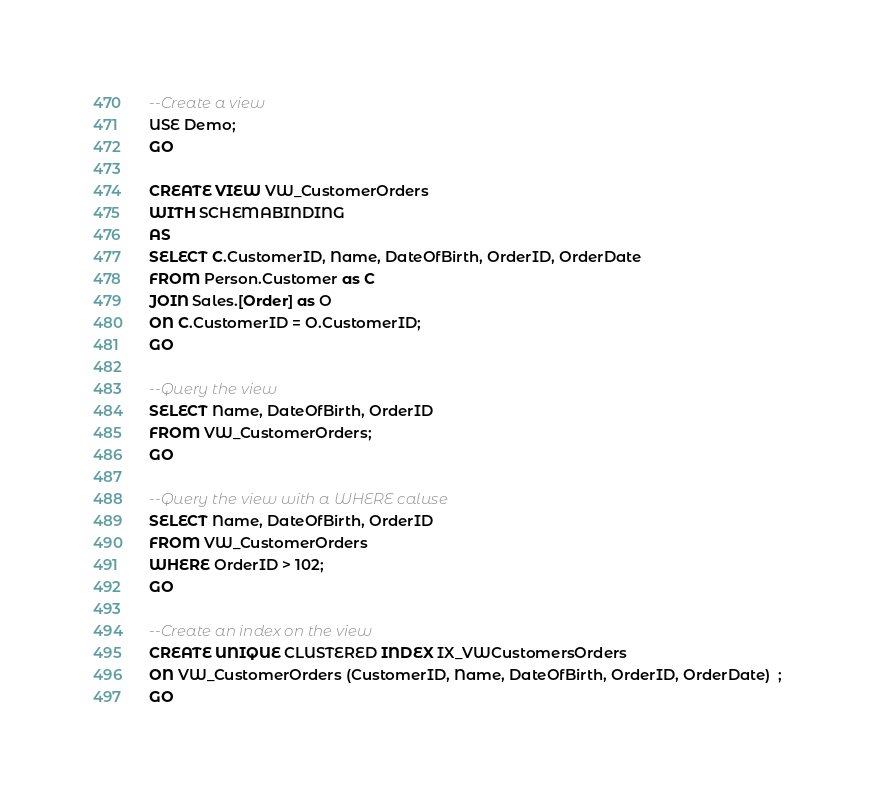Convert code to text. <code><loc_0><loc_0><loc_500><loc_500><_SQL_>--Create a view
USE Demo;
GO

CREATE VIEW VW_CustomerOrders
WITH SCHEMABINDING
AS
SELECT C.CustomerID, Name, DateOfBirth, OrderID, OrderDate
FROM Person.Customer as C
JOIN Sales.[Order] as O
ON C.CustomerID = O.CustomerID;
GO

--Query the view
SELECT Name, DateOfBirth, OrderID
FROM VW_CustomerOrders;
GO

--Query the view with a WHERE caluse
SELECT Name, DateOfBirth, OrderID
FROM VW_CustomerOrders
WHERE OrderID > 102;
GO

--Create an index on the view
CREATE UNIQUE CLUSTERED INDEX IX_VWCustomersOrders
ON VW_CustomerOrders (CustomerID, Name, DateOfBirth, OrderID, OrderDate)  ;
GO
</code> 